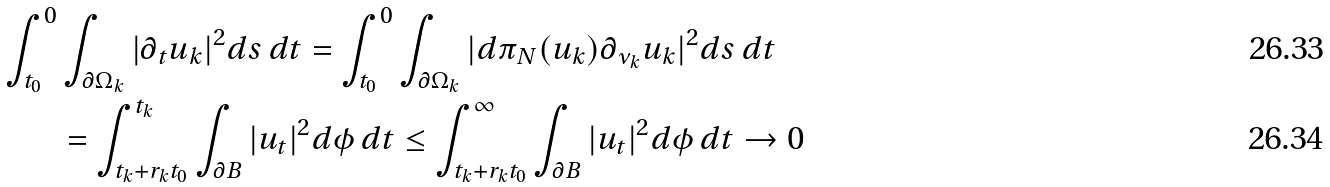<formula> <loc_0><loc_0><loc_500><loc_500>\int _ { t _ { 0 } } ^ { 0 } & \int _ { \partial \Omega _ { k } } | \partial _ { t } u _ { k } | ^ { 2 } d s \, d t = \int _ { t _ { 0 } } ^ { 0 } \int _ { \partial \Omega _ { k } } | d \pi _ { N } ( u _ { k } ) \partial _ { \nu _ { k } } u _ { k } | ^ { 2 } d s \, d t \\ & = \int _ { t _ { k } + r _ { k } t _ { 0 } } ^ { t _ { k } } \int _ { \partial B } | u _ { t } | ^ { 2 } d \phi \, d t \leq \int _ { t _ { k } + r _ { k } t _ { 0 } } ^ { \infty } \int _ { \partial B } | u _ { t } | ^ { 2 } d \phi \, d t \to 0</formula> 